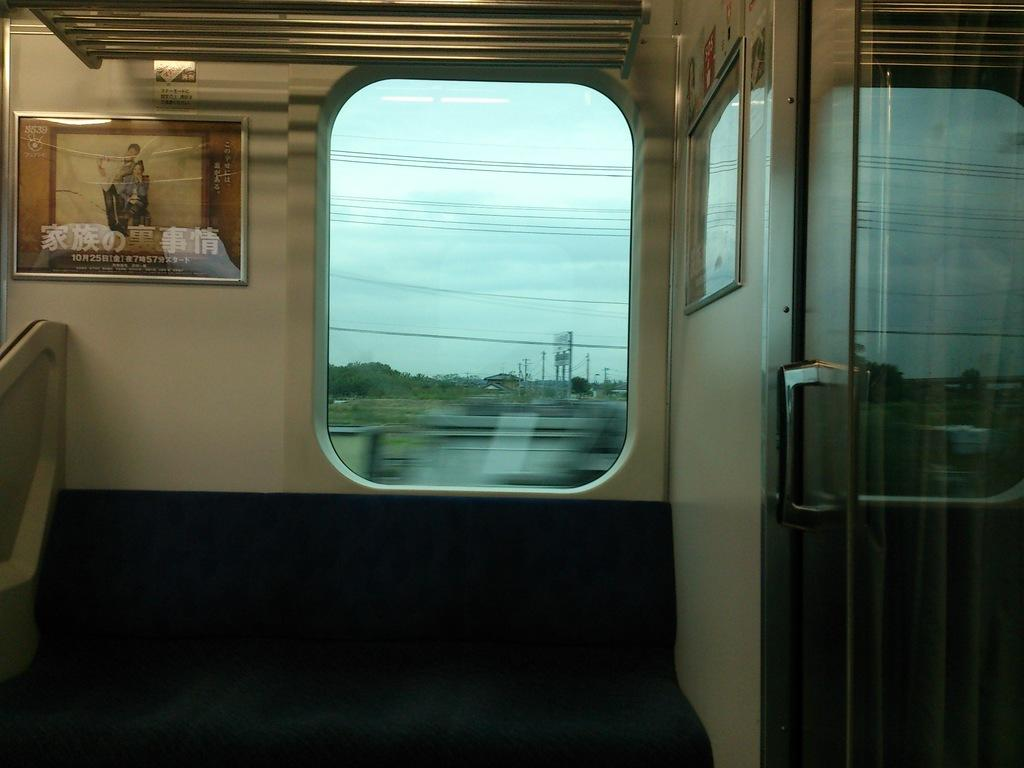What type of location is depicted in the image? The image is an inside view of a train. What structural elements can be seen in the image? There are frames and a glass door visible in the image. What feature allows passengers to see outside the train? There is a window in the image. What are the rods at the top of the image used for? The rods at the top of the image are likely used for hanging or supporting various items. What type of bell can be heard ringing in the image? There is no bell present in the image, and therefore no sound can be heard. 